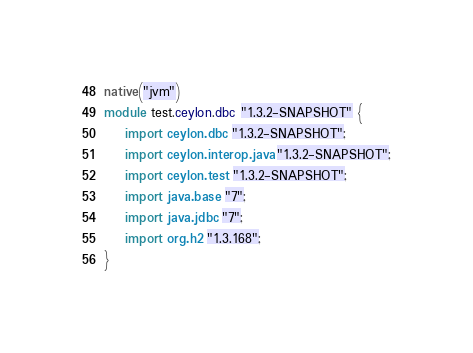<code> <loc_0><loc_0><loc_500><loc_500><_Ceylon_>native("jvm")
module test.ceylon.dbc "1.3.2-SNAPSHOT" {
    import ceylon.dbc "1.3.2-SNAPSHOT";
    import ceylon.interop.java "1.3.2-SNAPSHOT";
    import ceylon.test "1.3.2-SNAPSHOT";
    import java.base "7";
    import java.jdbc "7";
    import org.h2 "1.3.168";
}
</code> 